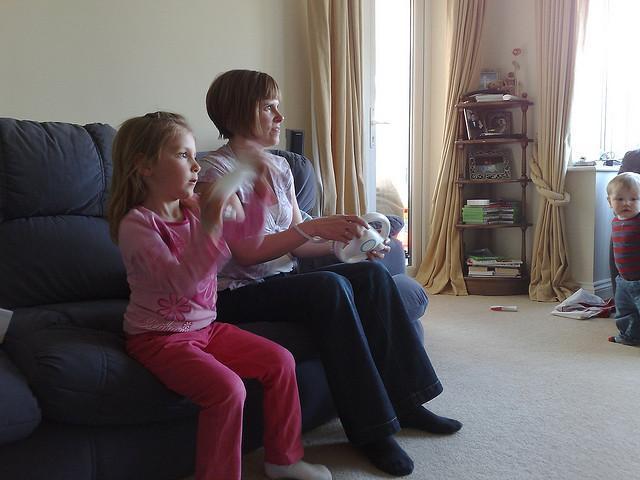What are the people on the couch looking at?
Make your selection from the four choices given to correctly answer the question.
Options: Mirror, child, picture window, gaming screen. Gaming screen. 